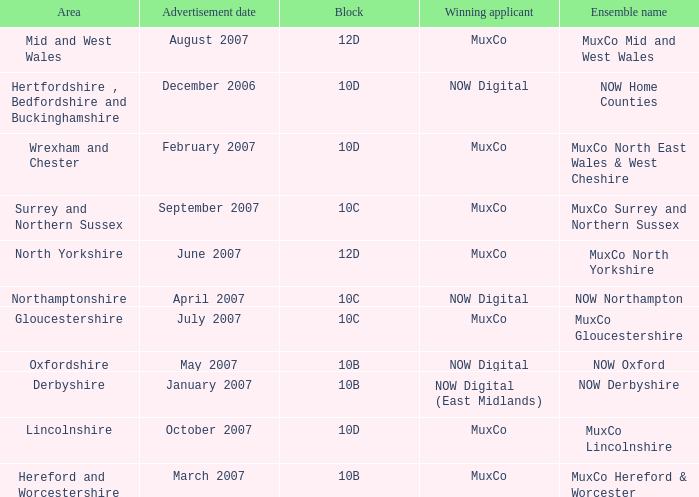Which Block does Northamptonshire Area have? 10C. 